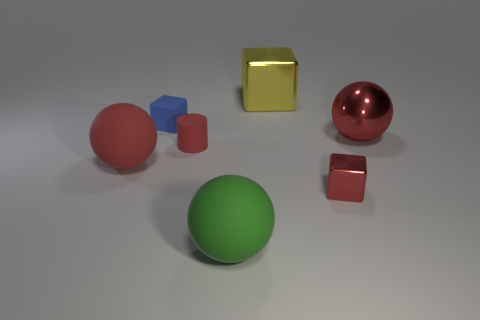The green matte sphere is what size?
Offer a terse response. Large. Do the green rubber thing and the red metal cube have the same size?
Your response must be concise. No. There is a block that is to the right of the tiny red cylinder and behind the small cylinder; what is its color?
Your answer should be very brief. Yellow. How many yellow blocks have the same material as the small blue block?
Offer a very short reply. 0. How many red metallic objects are there?
Your answer should be very brief. 2. Is the size of the matte cylinder the same as the red ball on the left side of the red matte cylinder?
Give a very brief answer. No. What is the material of the large sphere in front of the red sphere that is left of the big yellow block?
Make the answer very short. Rubber. There is a sphere to the right of the small red metal cube that is behind the green rubber sphere that is in front of the small red rubber cylinder; how big is it?
Keep it short and to the point. Large. Is the shape of the green rubber thing the same as the small object on the right side of the green thing?
Offer a very short reply. No. What is the material of the red cube?
Provide a short and direct response. Metal. 